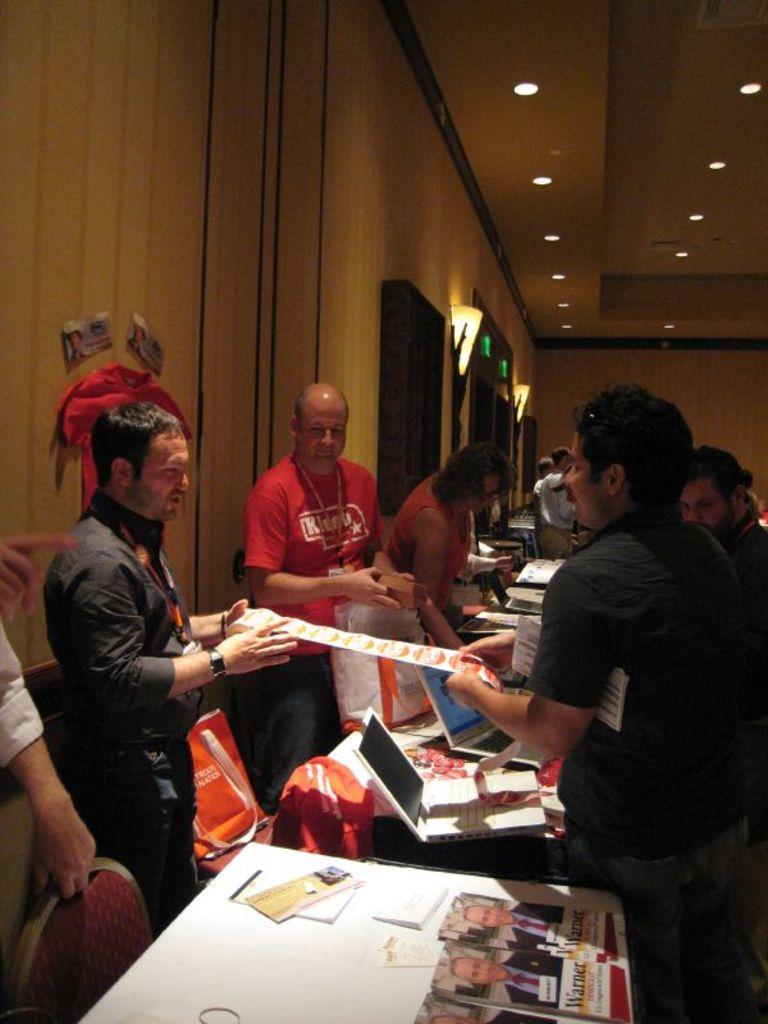What is the name of the guy on the pamphlet on the bottom?
Your response must be concise. Warner. 